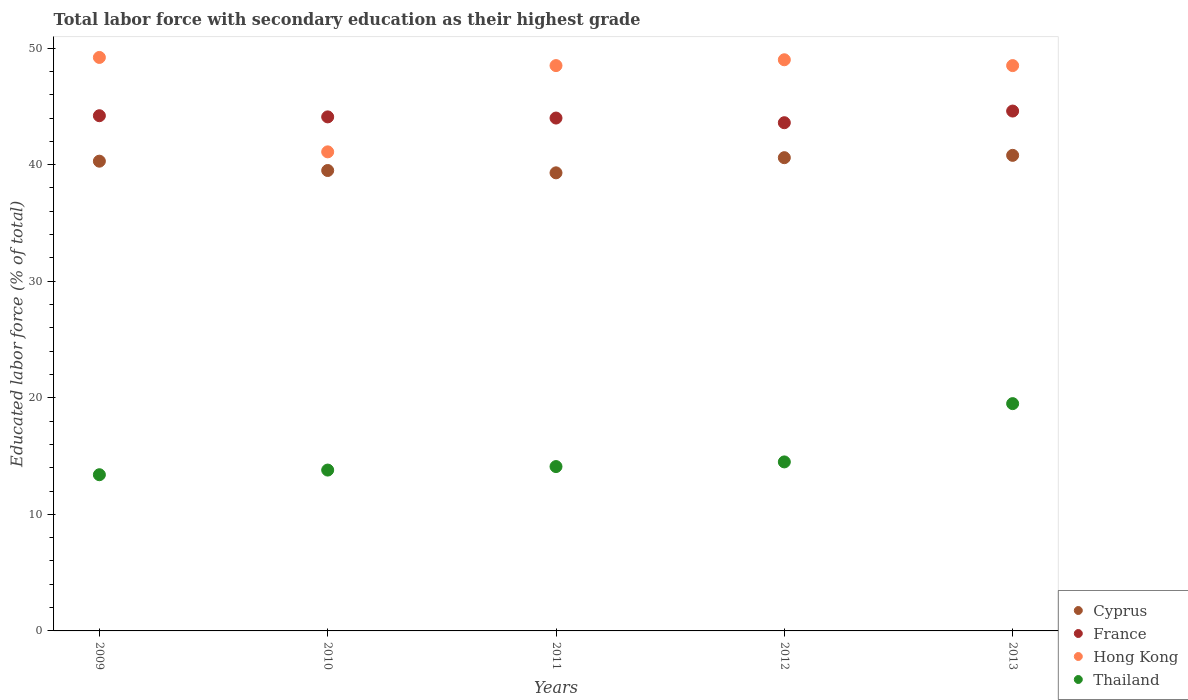What is the percentage of total labor force with primary education in Hong Kong in 2013?
Your response must be concise. 48.5. Across all years, what is the maximum percentage of total labor force with primary education in Cyprus?
Your answer should be very brief. 40.8. Across all years, what is the minimum percentage of total labor force with primary education in Cyprus?
Your answer should be very brief. 39.3. What is the total percentage of total labor force with primary education in Thailand in the graph?
Your answer should be very brief. 75.3. What is the difference between the percentage of total labor force with primary education in Cyprus in 2012 and the percentage of total labor force with primary education in Thailand in 2009?
Your answer should be very brief. 27.2. What is the average percentage of total labor force with primary education in Hong Kong per year?
Ensure brevity in your answer.  47.26. In the year 2013, what is the difference between the percentage of total labor force with primary education in France and percentage of total labor force with primary education in Cyprus?
Keep it short and to the point. 3.8. In how many years, is the percentage of total labor force with primary education in Hong Kong greater than 12 %?
Provide a succinct answer. 5. What is the ratio of the percentage of total labor force with primary education in France in 2011 to that in 2012?
Your answer should be compact. 1.01. Is the difference between the percentage of total labor force with primary education in France in 2009 and 2013 greater than the difference between the percentage of total labor force with primary education in Cyprus in 2009 and 2013?
Ensure brevity in your answer.  Yes. What is the difference between the highest and the second highest percentage of total labor force with primary education in Hong Kong?
Keep it short and to the point. 0.2. What is the difference between the highest and the lowest percentage of total labor force with primary education in France?
Your answer should be compact. 1. In how many years, is the percentage of total labor force with primary education in Hong Kong greater than the average percentage of total labor force with primary education in Hong Kong taken over all years?
Offer a terse response. 4. Is the sum of the percentage of total labor force with primary education in Cyprus in 2010 and 2012 greater than the maximum percentage of total labor force with primary education in France across all years?
Offer a terse response. Yes. Is it the case that in every year, the sum of the percentage of total labor force with primary education in France and percentage of total labor force with primary education in Thailand  is greater than the sum of percentage of total labor force with primary education in Cyprus and percentage of total labor force with primary education in Hong Kong?
Ensure brevity in your answer.  No. Is it the case that in every year, the sum of the percentage of total labor force with primary education in Thailand and percentage of total labor force with primary education in France  is greater than the percentage of total labor force with primary education in Cyprus?
Offer a very short reply. Yes. Is the percentage of total labor force with primary education in Thailand strictly less than the percentage of total labor force with primary education in Hong Kong over the years?
Offer a very short reply. Yes. How many dotlines are there?
Your response must be concise. 4. How many years are there in the graph?
Ensure brevity in your answer.  5. Are the values on the major ticks of Y-axis written in scientific E-notation?
Give a very brief answer. No. Does the graph contain grids?
Give a very brief answer. No. How are the legend labels stacked?
Your response must be concise. Vertical. What is the title of the graph?
Keep it short and to the point. Total labor force with secondary education as their highest grade. What is the label or title of the Y-axis?
Give a very brief answer. Educated labor force (% of total). What is the Educated labor force (% of total) of Cyprus in 2009?
Offer a very short reply. 40.3. What is the Educated labor force (% of total) in France in 2009?
Make the answer very short. 44.2. What is the Educated labor force (% of total) in Hong Kong in 2009?
Your answer should be very brief. 49.2. What is the Educated labor force (% of total) of Thailand in 2009?
Provide a succinct answer. 13.4. What is the Educated labor force (% of total) in Cyprus in 2010?
Ensure brevity in your answer.  39.5. What is the Educated labor force (% of total) in France in 2010?
Your answer should be compact. 44.1. What is the Educated labor force (% of total) in Hong Kong in 2010?
Provide a short and direct response. 41.1. What is the Educated labor force (% of total) in Thailand in 2010?
Your answer should be very brief. 13.8. What is the Educated labor force (% of total) in Cyprus in 2011?
Make the answer very short. 39.3. What is the Educated labor force (% of total) of Hong Kong in 2011?
Keep it short and to the point. 48.5. What is the Educated labor force (% of total) of Thailand in 2011?
Your answer should be compact. 14.1. What is the Educated labor force (% of total) of Cyprus in 2012?
Make the answer very short. 40.6. What is the Educated labor force (% of total) of France in 2012?
Provide a succinct answer. 43.6. What is the Educated labor force (% of total) in Thailand in 2012?
Your answer should be compact. 14.5. What is the Educated labor force (% of total) of Cyprus in 2013?
Provide a short and direct response. 40.8. What is the Educated labor force (% of total) of France in 2013?
Your response must be concise. 44.6. What is the Educated labor force (% of total) of Hong Kong in 2013?
Your response must be concise. 48.5. What is the Educated labor force (% of total) of Thailand in 2013?
Ensure brevity in your answer.  19.5. Across all years, what is the maximum Educated labor force (% of total) of Cyprus?
Offer a very short reply. 40.8. Across all years, what is the maximum Educated labor force (% of total) of France?
Make the answer very short. 44.6. Across all years, what is the maximum Educated labor force (% of total) of Hong Kong?
Your response must be concise. 49.2. Across all years, what is the maximum Educated labor force (% of total) of Thailand?
Give a very brief answer. 19.5. Across all years, what is the minimum Educated labor force (% of total) of Cyprus?
Your answer should be compact. 39.3. Across all years, what is the minimum Educated labor force (% of total) in France?
Your answer should be very brief. 43.6. Across all years, what is the minimum Educated labor force (% of total) in Hong Kong?
Provide a succinct answer. 41.1. Across all years, what is the minimum Educated labor force (% of total) of Thailand?
Give a very brief answer. 13.4. What is the total Educated labor force (% of total) in Cyprus in the graph?
Your response must be concise. 200.5. What is the total Educated labor force (% of total) in France in the graph?
Offer a terse response. 220.5. What is the total Educated labor force (% of total) of Hong Kong in the graph?
Offer a very short reply. 236.3. What is the total Educated labor force (% of total) of Thailand in the graph?
Keep it short and to the point. 75.3. What is the difference between the Educated labor force (% of total) in Thailand in 2009 and that in 2010?
Your answer should be compact. -0.4. What is the difference between the Educated labor force (% of total) in Hong Kong in 2009 and that in 2011?
Your answer should be compact. 0.7. What is the difference between the Educated labor force (% of total) in Thailand in 2009 and that in 2011?
Offer a very short reply. -0.7. What is the difference between the Educated labor force (% of total) of Cyprus in 2009 and that in 2012?
Ensure brevity in your answer.  -0.3. What is the difference between the Educated labor force (% of total) in France in 2009 and that in 2013?
Your answer should be very brief. -0.4. What is the difference between the Educated labor force (% of total) in Hong Kong in 2009 and that in 2013?
Ensure brevity in your answer.  0.7. What is the difference between the Educated labor force (% of total) of Cyprus in 2010 and that in 2011?
Your answer should be very brief. 0.2. What is the difference between the Educated labor force (% of total) in France in 2010 and that in 2011?
Ensure brevity in your answer.  0.1. What is the difference between the Educated labor force (% of total) of Thailand in 2010 and that in 2012?
Keep it short and to the point. -0.7. What is the difference between the Educated labor force (% of total) of Thailand in 2010 and that in 2013?
Your answer should be very brief. -5.7. What is the difference between the Educated labor force (% of total) in Cyprus in 2011 and that in 2012?
Offer a very short reply. -1.3. What is the difference between the Educated labor force (% of total) of Thailand in 2011 and that in 2012?
Offer a very short reply. -0.4. What is the difference between the Educated labor force (% of total) in Cyprus in 2011 and that in 2013?
Offer a terse response. -1.5. What is the difference between the Educated labor force (% of total) of France in 2011 and that in 2013?
Your response must be concise. -0.6. What is the difference between the Educated labor force (% of total) in Cyprus in 2012 and that in 2013?
Give a very brief answer. -0.2. What is the difference between the Educated labor force (% of total) in Thailand in 2012 and that in 2013?
Give a very brief answer. -5. What is the difference between the Educated labor force (% of total) of Cyprus in 2009 and the Educated labor force (% of total) of France in 2010?
Provide a short and direct response. -3.8. What is the difference between the Educated labor force (% of total) of Cyprus in 2009 and the Educated labor force (% of total) of Hong Kong in 2010?
Provide a short and direct response. -0.8. What is the difference between the Educated labor force (% of total) in Cyprus in 2009 and the Educated labor force (% of total) in Thailand in 2010?
Offer a terse response. 26.5. What is the difference between the Educated labor force (% of total) of France in 2009 and the Educated labor force (% of total) of Hong Kong in 2010?
Offer a terse response. 3.1. What is the difference between the Educated labor force (% of total) in France in 2009 and the Educated labor force (% of total) in Thailand in 2010?
Provide a succinct answer. 30.4. What is the difference between the Educated labor force (% of total) in Hong Kong in 2009 and the Educated labor force (% of total) in Thailand in 2010?
Ensure brevity in your answer.  35.4. What is the difference between the Educated labor force (% of total) of Cyprus in 2009 and the Educated labor force (% of total) of France in 2011?
Offer a terse response. -3.7. What is the difference between the Educated labor force (% of total) in Cyprus in 2009 and the Educated labor force (% of total) in Hong Kong in 2011?
Your answer should be compact. -8.2. What is the difference between the Educated labor force (% of total) of Cyprus in 2009 and the Educated labor force (% of total) of Thailand in 2011?
Your answer should be compact. 26.2. What is the difference between the Educated labor force (% of total) of France in 2009 and the Educated labor force (% of total) of Thailand in 2011?
Ensure brevity in your answer.  30.1. What is the difference between the Educated labor force (% of total) in Hong Kong in 2009 and the Educated labor force (% of total) in Thailand in 2011?
Provide a short and direct response. 35.1. What is the difference between the Educated labor force (% of total) of Cyprus in 2009 and the Educated labor force (% of total) of Hong Kong in 2012?
Ensure brevity in your answer.  -8.7. What is the difference between the Educated labor force (% of total) of Cyprus in 2009 and the Educated labor force (% of total) of Thailand in 2012?
Your response must be concise. 25.8. What is the difference between the Educated labor force (% of total) in France in 2009 and the Educated labor force (% of total) in Thailand in 2012?
Your response must be concise. 29.7. What is the difference between the Educated labor force (% of total) in Hong Kong in 2009 and the Educated labor force (% of total) in Thailand in 2012?
Offer a terse response. 34.7. What is the difference between the Educated labor force (% of total) in Cyprus in 2009 and the Educated labor force (% of total) in Thailand in 2013?
Your answer should be compact. 20.8. What is the difference between the Educated labor force (% of total) of France in 2009 and the Educated labor force (% of total) of Thailand in 2013?
Your answer should be compact. 24.7. What is the difference between the Educated labor force (% of total) of Hong Kong in 2009 and the Educated labor force (% of total) of Thailand in 2013?
Your answer should be very brief. 29.7. What is the difference between the Educated labor force (% of total) in Cyprus in 2010 and the Educated labor force (% of total) in Hong Kong in 2011?
Offer a terse response. -9. What is the difference between the Educated labor force (% of total) of Cyprus in 2010 and the Educated labor force (% of total) of Thailand in 2011?
Provide a short and direct response. 25.4. What is the difference between the Educated labor force (% of total) of France in 2010 and the Educated labor force (% of total) of Thailand in 2011?
Ensure brevity in your answer.  30. What is the difference between the Educated labor force (% of total) in Hong Kong in 2010 and the Educated labor force (% of total) in Thailand in 2011?
Provide a succinct answer. 27. What is the difference between the Educated labor force (% of total) in Cyprus in 2010 and the Educated labor force (% of total) in France in 2012?
Provide a succinct answer. -4.1. What is the difference between the Educated labor force (% of total) in Cyprus in 2010 and the Educated labor force (% of total) in Thailand in 2012?
Offer a very short reply. 25. What is the difference between the Educated labor force (% of total) in France in 2010 and the Educated labor force (% of total) in Thailand in 2012?
Give a very brief answer. 29.6. What is the difference between the Educated labor force (% of total) in Hong Kong in 2010 and the Educated labor force (% of total) in Thailand in 2012?
Your answer should be very brief. 26.6. What is the difference between the Educated labor force (% of total) in Cyprus in 2010 and the Educated labor force (% of total) in Hong Kong in 2013?
Your answer should be very brief. -9. What is the difference between the Educated labor force (% of total) in France in 2010 and the Educated labor force (% of total) in Hong Kong in 2013?
Make the answer very short. -4.4. What is the difference between the Educated labor force (% of total) of France in 2010 and the Educated labor force (% of total) of Thailand in 2013?
Your response must be concise. 24.6. What is the difference between the Educated labor force (% of total) in Hong Kong in 2010 and the Educated labor force (% of total) in Thailand in 2013?
Offer a very short reply. 21.6. What is the difference between the Educated labor force (% of total) of Cyprus in 2011 and the Educated labor force (% of total) of Hong Kong in 2012?
Offer a terse response. -9.7. What is the difference between the Educated labor force (% of total) of Cyprus in 2011 and the Educated labor force (% of total) of Thailand in 2012?
Ensure brevity in your answer.  24.8. What is the difference between the Educated labor force (% of total) in France in 2011 and the Educated labor force (% of total) in Thailand in 2012?
Offer a very short reply. 29.5. What is the difference between the Educated labor force (% of total) of Cyprus in 2011 and the Educated labor force (% of total) of France in 2013?
Your answer should be very brief. -5.3. What is the difference between the Educated labor force (% of total) in Cyprus in 2011 and the Educated labor force (% of total) in Hong Kong in 2013?
Provide a short and direct response. -9.2. What is the difference between the Educated labor force (% of total) of Cyprus in 2011 and the Educated labor force (% of total) of Thailand in 2013?
Provide a succinct answer. 19.8. What is the difference between the Educated labor force (% of total) of France in 2011 and the Educated labor force (% of total) of Hong Kong in 2013?
Your response must be concise. -4.5. What is the difference between the Educated labor force (% of total) of France in 2011 and the Educated labor force (% of total) of Thailand in 2013?
Make the answer very short. 24.5. What is the difference between the Educated labor force (% of total) of Cyprus in 2012 and the Educated labor force (% of total) of Thailand in 2013?
Your response must be concise. 21.1. What is the difference between the Educated labor force (% of total) of France in 2012 and the Educated labor force (% of total) of Thailand in 2013?
Make the answer very short. 24.1. What is the difference between the Educated labor force (% of total) in Hong Kong in 2012 and the Educated labor force (% of total) in Thailand in 2013?
Give a very brief answer. 29.5. What is the average Educated labor force (% of total) in Cyprus per year?
Offer a very short reply. 40.1. What is the average Educated labor force (% of total) of France per year?
Offer a terse response. 44.1. What is the average Educated labor force (% of total) of Hong Kong per year?
Your answer should be compact. 47.26. What is the average Educated labor force (% of total) of Thailand per year?
Your answer should be compact. 15.06. In the year 2009, what is the difference between the Educated labor force (% of total) of Cyprus and Educated labor force (% of total) of France?
Provide a succinct answer. -3.9. In the year 2009, what is the difference between the Educated labor force (% of total) of Cyprus and Educated labor force (% of total) of Hong Kong?
Your answer should be very brief. -8.9. In the year 2009, what is the difference between the Educated labor force (% of total) in Cyprus and Educated labor force (% of total) in Thailand?
Keep it short and to the point. 26.9. In the year 2009, what is the difference between the Educated labor force (% of total) of France and Educated labor force (% of total) of Thailand?
Keep it short and to the point. 30.8. In the year 2009, what is the difference between the Educated labor force (% of total) in Hong Kong and Educated labor force (% of total) in Thailand?
Keep it short and to the point. 35.8. In the year 2010, what is the difference between the Educated labor force (% of total) in Cyprus and Educated labor force (% of total) in Thailand?
Make the answer very short. 25.7. In the year 2010, what is the difference between the Educated labor force (% of total) in France and Educated labor force (% of total) in Hong Kong?
Offer a terse response. 3. In the year 2010, what is the difference between the Educated labor force (% of total) of France and Educated labor force (% of total) of Thailand?
Provide a succinct answer. 30.3. In the year 2010, what is the difference between the Educated labor force (% of total) of Hong Kong and Educated labor force (% of total) of Thailand?
Give a very brief answer. 27.3. In the year 2011, what is the difference between the Educated labor force (% of total) of Cyprus and Educated labor force (% of total) of Thailand?
Your answer should be compact. 25.2. In the year 2011, what is the difference between the Educated labor force (% of total) of France and Educated labor force (% of total) of Thailand?
Make the answer very short. 29.9. In the year 2011, what is the difference between the Educated labor force (% of total) of Hong Kong and Educated labor force (% of total) of Thailand?
Make the answer very short. 34.4. In the year 2012, what is the difference between the Educated labor force (% of total) of Cyprus and Educated labor force (% of total) of Thailand?
Offer a terse response. 26.1. In the year 2012, what is the difference between the Educated labor force (% of total) of France and Educated labor force (% of total) of Hong Kong?
Make the answer very short. -5.4. In the year 2012, what is the difference between the Educated labor force (% of total) of France and Educated labor force (% of total) of Thailand?
Make the answer very short. 29.1. In the year 2012, what is the difference between the Educated labor force (% of total) in Hong Kong and Educated labor force (% of total) in Thailand?
Keep it short and to the point. 34.5. In the year 2013, what is the difference between the Educated labor force (% of total) of Cyprus and Educated labor force (% of total) of France?
Provide a succinct answer. -3.8. In the year 2013, what is the difference between the Educated labor force (% of total) of Cyprus and Educated labor force (% of total) of Hong Kong?
Ensure brevity in your answer.  -7.7. In the year 2013, what is the difference between the Educated labor force (% of total) of Cyprus and Educated labor force (% of total) of Thailand?
Ensure brevity in your answer.  21.3. In the year 2013, what is the difference between the Educated labor force (% of total) of France and Educated labor force (% of total) of Hong Kong?
Your answer should be very brief. -3.9. In the year 2013, what is the difference between the Educated labor force (% of total) of France and Educated labor force (% of total) of Thailand?
Your response must be concise. 25.1. What is the ratio of the Educated labor force (% of total) in Cyprus in 2009 to that in 2010?
Offer a terse response. 1.02. What is the ratio of the Educated labor force (% of total) in France in 2009 to that in 2010?
Ensure brevity in your answer.  1. What is the ratio of the Educated labor force (% of total) in Hong Kong in 2009 to that in 2010?
Your answer should be compact. 1.2. What is the ratio of the Educated labor force (% of total) of Cyprus in 2009 to that in 2011?
Provide a succinct answer. 1.03. What is the ratio of the Educated labor force (% of total) in France in 2009 to that in 2011?
Provide a succinct answer. 1. What is the ratio of the Educated labor force (% of total) of Hong Kong in 2009 to that in 2011?
Make the answer very short. 1.01. What is the ratio of the Educated labor force (% of total) of Thailand in 2009 to that in 2011?
Your answer should be compact. 0.95. What is the ratio of the Educated labor force (% of total) of France in 2009 to that in 2012?
Offer a terse response. 1.01. What is the ratio of the Educated labor force (% of total) in Thailand in 2009 to that in 2012?
Your response must be concise. 0.92. What is the ratio of the Educated labor force (% of total) of Hong Kong in 2009 to that in 2013?
Your answer should be very brief. 1.01. What is the ratio of the Educated labor force (% of total) in Thailand in 2009 to that in 2013?
Give a very brief answer. 0.69. What is the ratio of the Educated labor force (% of total) in Cyprus in 2010 to that in 2011?
Provide a succinct answer. 1.01. What is the ratio of the Educated labor force (% of total) of France in 2010 to that in 2011?
Give a very brief answer. 1. What is the ratio of the Educated labor force (% of total) in Hong Kong in 2010 to that in 2011?
Make the answer very short. 0.85. What is the ratio of the Educated labor force (% of total) of Thailand in 2010 to that in 2011?
Provide a short and direct response. 0.98. What is the ratio of the Educated labor force (% of total) of Cyprus in 2010 to that in 2012?
Keep it short and to the point. 0.97. What is the ratio of the Educated labor force (% of total) of France in 2010 to that in 2012?
Provide a succinct answer. 1.01. What is the ratio of the Educated labor force (% of total) in Hong Kong in 2010 to that in 2012?
Give a very brief answer. 0.84. What is the ratio of the Educated labor force (% of total) in Thailand in 2010 to that in 2012?
Give a very brief answer. 0.95. What is the ratio of the Educated labor force (% of total) of Cyprus in 2010 to that in 2013?
Offer a very short reply. 0.97. What is the ratio of the Educated labor force (% of total) in Hong Kong in 2010 to that in 2013?
Make the answer very short. 0.85. What is the ratio of the Educated labor force (% of total) of Thailand in 2010 to that in 2013?
Provide a short and direct response. 0.71. What is the ratio of the Educated labor force (% of total) in Cyprus in 2011 to that in 2012?
Your answer should be very brief. 0.97. What is the ratio of the Educated labor force (% of total) in France in 2011 to that in 2012?
Offer a very short reply. 1.01. What is the ratio of the Educated labor force (% of total) of Thailand in 2011 to that in 2012?
Your response must be concise. 0.97. What is the ratio of the Educated labor force (% of total) in Cyprus in 2011 to that in 2013?
Your response must be concise. 0.96. What is the ratio of the Educated labor force (% of total) in France in 2011 to that in 2013?
Offer a terse response. 0.99. What is the ratio of the Educated labor force (% of total) in Hong Kong in 2011 to that in 2013?
Ensure brevity in your answer.  1. What is the ratio of the Educated labor force (% of total) in Thailand in 2011 to that in 2013?
Provide a succinct answer. 0.72. What is the ratio of the Educated labor force (% of total) in France in 2012 to that in 2013?
Offer a terse response. 0.98. What is the ratio of the Educated labor force (% of total) in Hong Kong in 2012 to that in 2013?
Offer a very short reply. 1.01. What is the ratio of the Educated labor force (% of total) of Thailand in 2012 to that in 2013?
Provide a succinct answer. 0.74. What is the difference between the highest and the second highest Educated labor force (% of total) of Hong Kong?
Offer a very short reply. 0.2. What is the difference between the highest and the lowest Educated labor force (% of total) of France?
Offer a very short reply. 1. What is the difference between the highest and the lowest Educated labor force (% of total) of Hong Kong?
Offer a very short reply. 8.1. What is the difference between the highest and the lowest Educated labor force (% of total) in Thailand?
Provide a short and direct response. 6.1. 